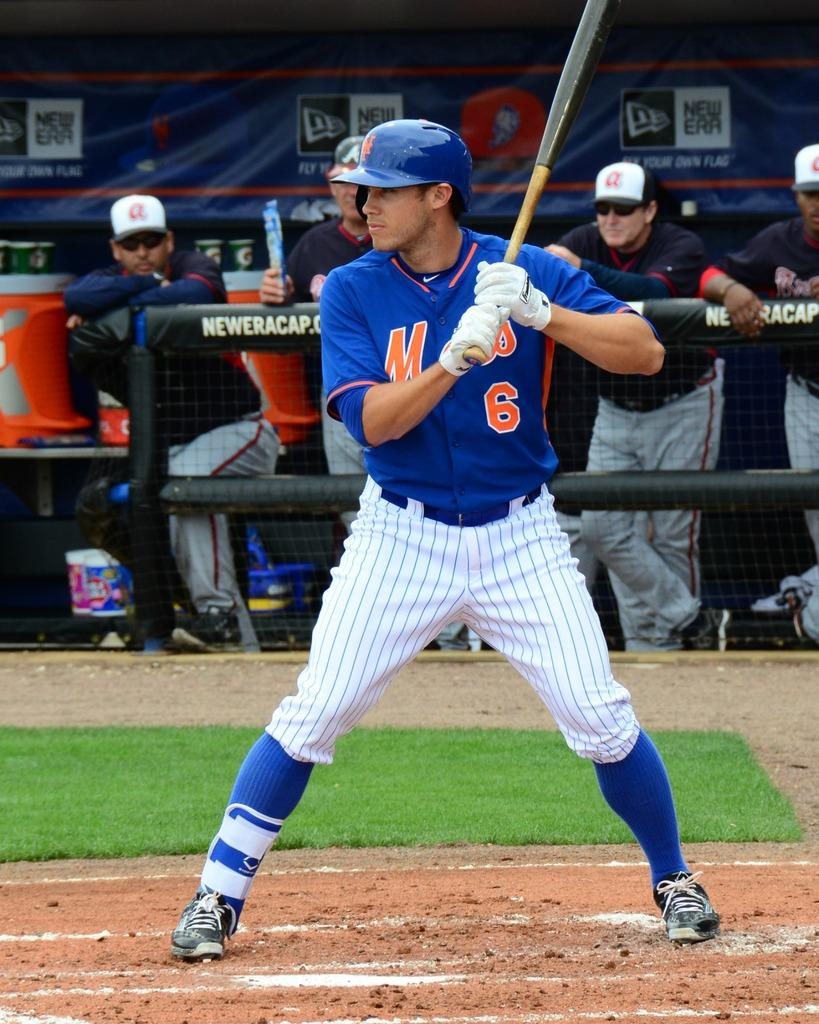<image>
Provide a brief description of the given image. A batter in a Mets jersey with the number 6 on it. 